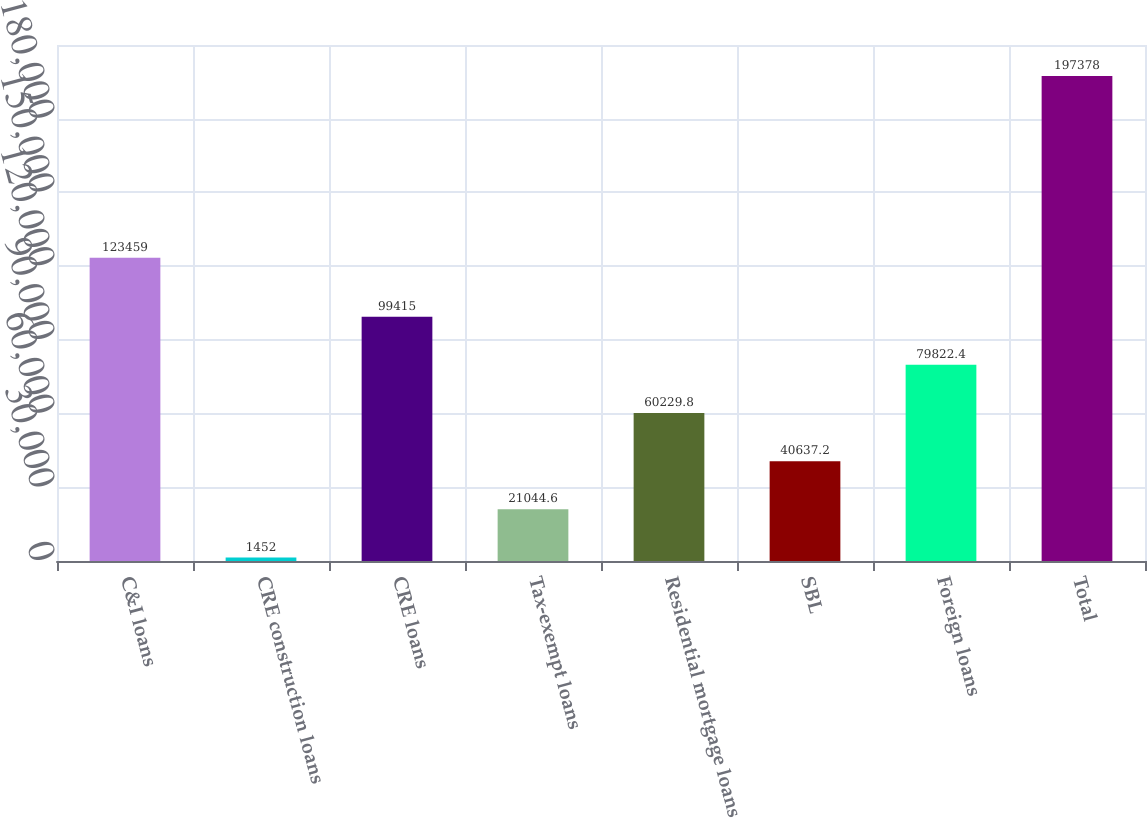<chart> <loc_0><loc_0><loc_500><loc_500><bar_chart><fcel>C&I loans<fcel>CRE construction loans<fcel>CRE loans<fcel>Tax-exempt loans<fcel>Residential mortgage loans<fcel>SBL<fcel>Foreign loans<fcel>Total<nl><fcel>123459<fcel>1452<fcel>99415<fcel>21044.6<fcel>60229.8<fcel>40637.2<fcel>79822.4<fcel>197378<nl></chart> 